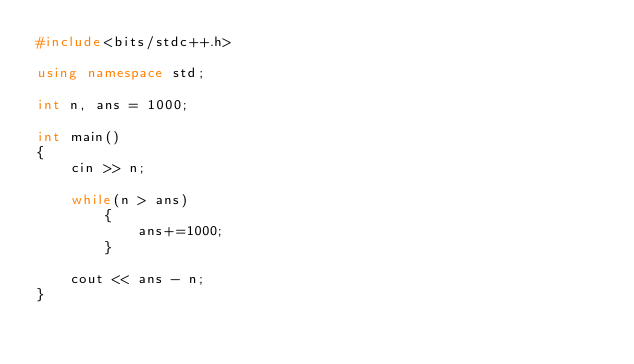<code> <loc_0><loc_0><loc_500><loc_500><_C++_>#include<bits/stdc++.h>

using namespace std;

int n, ans = 1000;

int main()
{
	cin >> n;
	
	while(n > ans)
		{
			ans+=1000;
		}
	
	cout << ans - n;
}
</code> 